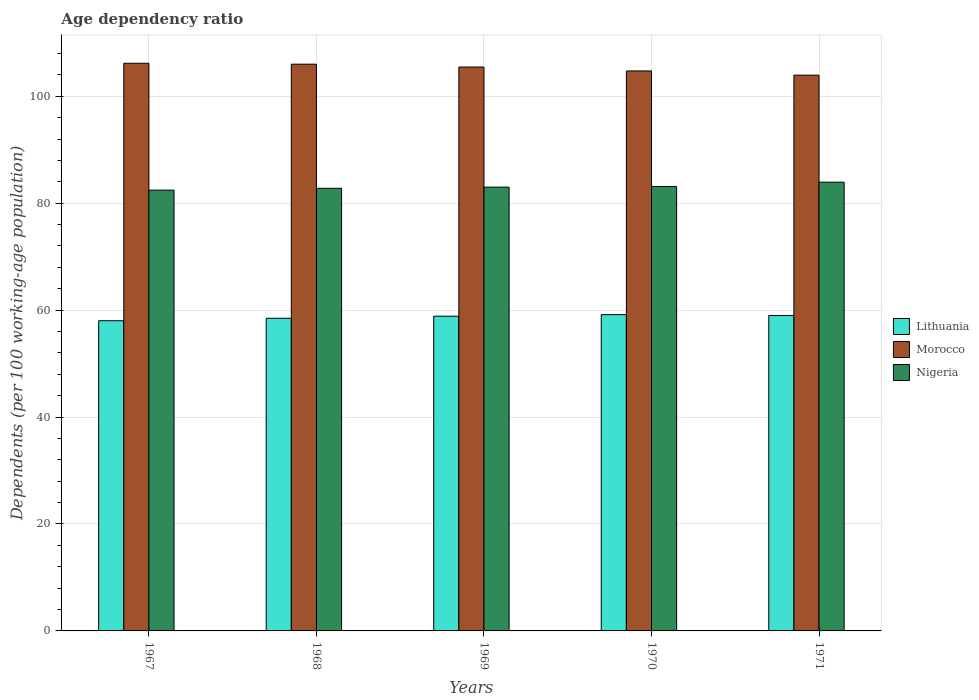How many groups of bars are there?
Offer a very short reply. 5. Are the number of bars per tick equal to the number of legend labels?
Your answer should be very brief. Yes. Are the number of bars on each tick of the X-axis equal?
Your response must be concise. Yes. How many bars are there on the 1st tick from the left?
Ensure brevity in your answer.  3. How many bars are there on the 5th tick from the right?
Offer a terse response. 3. What is the age dependency ratio in in Nigeria in 1971?
Ensure brevity in your answer.  83.94. Across all years, what is the maximum age dependency ratio in in Lithuania?
Ensure brevity in your answer.  59.16. Across all years, what is the minimum age dependency ratio in in Nigeria?
Give a very brief answer. 82.45. In which year was the age dependency ratio in in Morocco maximum?
Provide a succinct answer. 1967. In which year was the age dependency ratio in in Lithuania minimum?
Your answer should be very brief. 1967. What is the total age dependency ratio in in Morocco in the graph?
Your response must be concise. 526.37. What is the difference between the age dependency ratio in in Lithuania in 1967 and that in 1968?
Give a very brief answer. -0.46. What is the difference between the age dependency ratio in in Lithuania in 1970 and the age dependency ratio in in Morocco in 1967?
Your response must be concise. -47.02. What is the average age dependency ratio in in Morocco per year?
Ensure brevity in your answer.  105.27. In the year 1971, what is the difference between the age dependency ratio in in Morocco and age dependency ratio in in Lithuania?
Provide a short and direct response. 44.96. In how many years, is the age dependency ratio in in Lithuania greater than 96 %?
Make the answer very short. 0. What is the ratio of the age dependency ratio in in Lithuania in 1967 to that in 1968?
Your response must be concise. 0.99. Is the age dependency ratio in in Morocco in 1967 less than that in 1968?
Your answer should be compact. No. Is the difference between the age dependency ratio in in Morocco in 1968 and 1970 greater than the difference between the age dependency ratio in in Lithuania in 1968 and 1970?
Offer a very short reply. Yes. What is the difference between the highest and the second highest age dependency ratio in in Morocco?
Provide a succinct answer. 0.17. What is the difference between the highest and the lowest age dependency ratio in in Nigeria?
Make the answer very short. 1.49. In how many years, is the age dependency ratio in in Morocco greater than the average age dependency ratio in in Morocco taken over all years?
Offer a very short reply. 3. Is the sum of the age dependency ratio in in Morocco in 1967 and 1970 greater than the maximum age dependency ratio in in Lithuania across all years?
Give a very brief answer. Yes. What does the 1st bar from the left in 1968 represents?
Your answer should be compact. Lithuania. What does the 1st bar from the right in 1967 represents?
Provide a short and direct response. Nigeria. How many bars are there?
Give a very brief answer. 15. How many years are there in the graph?
Provide a short and direct response. 5. Where does the legend appear in the graph?
Offer a very short reply. Center right. How are the legend labels stacked?
Provide a short and direct response. Vertical. What is the title of the graph?
Keep it short and to the point. Age dependency ratio. Does "Tunisia" appear as one of the legend labels in the graph?
Offer a very short reply. No. What is the label or title of the X-axis?
Your answer should be very brief. Years. What is the label or title of the Y-axis?
Your answer should be very brief. Dependents (per 100 working-age population). What is the Dependents (per 100 working-age population) in Lithuania in 1967?
Your answer should be very brief. 58.02. What is the Dependents (per 100 working-age population) in Morocco in 1967?
Offer a terse response. 106.18. What is the Dependents (per 100 working-age population) in Nigeria in 1967?
Keep it short and to the point. 82.45. What is the Dependents (per 100 working-age population) in Lithuania in 1968?
Your answer should be compact. 58.48. What is the Dependents (per 100 working-age population) in Morocco in 1968?
Offer a terse response. 106.01. What is the Dependents (per 100 working-age population) in Nigeria in 1968?
Your answer should be compact. 82.8. What is the Dependents (per 100 working-age population) of Lithuania in 1969?
Provide a short and direct response. 58.87. What is the Dependents (per 100 working-age population) in Morocco in 1969?
Your answer should be compact. 105.48. What is the Dependents (per 100 working-age population) of Nigeria in 1969?
Offer a very short reply. 83.01. What is the Dependents (per 100 working-age population) in Lithuania in 1970?
Your answer should be compact. 59.16. What is the Dependents (per 100 working-age population) in Morocco in 1970?
Your response must be concise. 104.74. What is the Dependents (per 100 working-age population) of Nigeria in 1970?
Provide a short and direct response. 83.14. What is the Dependents (per 100 working-age population) of Lithuania in 1971?
Your response must be concise. 59. What is the Dependents (per 100 working-age population) in Morocco in 1971?
Keep it short and to the point. 103.96. What is the Dependents (per 100 working-age population) of Nigeria in 1971?
Make the answer very short. 83.94. Across all years, what is the maximum Dependents (per 100 working-age population) in Lithuania?
Your response must be concise. 59.16. Across all years, what is the maximum Dependents (per 100 working-age population) of Morocco?
Provide a succinct answer. 106.18. Across all years, what is the maximum Dependents (per 100 working-age population) of Nigeria?
Provide a short and direct response. 83.94. Across all years, what is the minimum Dependents (per 100 working-age population) in Lithuania?
Your answer should be compact. 58.02. Across all years, what is the minimum Dependents (per 100 working-age population) in Morocco?
Offer a very short reply. 103.96. Across all years, what is the minimum Dependents (per 100 working-age population) in Nigeria?
Give a very brief answer. 82.45. What is the total Dependents (per 100 working-age population) of Lithuania in the graph?
Your answer should be very brief. 293.53. What is the total Dependents (per 100 working-age population) of Morocco in the graph?
Your answer should be compact. 526.37. What is the total Dependents (per 100 working-age population) of Nigeria in the graph?
Provide a succinct answer. 415.33. What is the difference between the Dependents (per 100 working-age population) in Lithuania in 1967 and that in 1968?
Provide a succinct answer. -0.46. What is the difference between the Dependents (per 100 working-age population) of Morocco in 1967 and that in 1968?
Your answer should be compact. 0.17. What is the difference between the Dependents (per 100 working-age population) in Nigeria in 1967 and that in 1968?
Your response must be concise. -0.35. What is the difference between the Dependents (per 100 working-age population) in Lithuania in 1967 and that in 1969?
Make the answer very short. -0.84. What is the difference between the Dependents (per 100 working-age population) of Morocco in 1967 and that in 1969?
Your answer should be compact. 0.7. What is the difference between the Dependents (per 100 working-age population) of Nigeria in 1967 and that in 1969?
Keep it short and to the point. -0.56. What is the difference between the Dependents (per 100 working-age population) of Lithuania in 1967 and that in 1970?
Provide a succinct answer. -1.14. What is the difference between the Dependents (per 100 working-age population) of Morocco in 1967 and that in 1970?
Provide a succinct answer. 1.44. What is the difference between the Dependents (per 100 working-age population) of Nigeria in 1967 and that in 1970?
Make the answer very short. -0.69. What is the difference between the Dependents (per 100 working-age population) in Lithuania in 1967 and that in 1971?
Make the answer very short. -0.98. What is the difference between the Dependents (per 100 working-age population) in Morocco in 1967 and that in 1971?
Make the answer very short. 2.23. What is the difference between the Dependents (per 100 working-age population) in Nigeria in 1967 and that in 1971?
Keep it short and to the point. -1.49. What is the difference between the Dependents (per 100 working-age population) of Lithuania in 1968 and that in 1969?
Provide a short and direct response. -0.38. What is the difference between the Dependents (per 100 working-age population) of Morocco in 1968 and that in 1969?
Provide a succinct answer. 0.53. What is the difference between the Dependents (per 100 working-age population) of Nigeria in 1968 and that in 1969?
Keep it short and to the point. -0.22. What is the difference between the Dependents (per 100 working-age population) of Lithuania in 1968 and that in 1970?
Provide a short and direct response. -0.68. What is the difference between the Dependents (per 100 working-age population) of Morocco in 1968 and that in 1970?
Your response must be concise. 1.27. What is the difference between the Dependents (per 100 working-age population) of Nigeria in 1968 and that in 1970?
Provide a short and direct response. -0.34. What is the difference between the Dependents (per 100 working-age population) in Lithuania in 1968 and that in 1971?
Give a very brief answer. -0.51. What is the difference between the Dependents (per 100 working-age population) in Morocco in 1968 and that in 1971?
Provide a succinct answer. 2.05. What is the difference between the Dependents (per 100 working-age population) in Nigeria in 1968 and that in 1971?
Your answer should be compact. -1.14. What is the difference between the Dependents (per 100 working-age population) of Lithuania in 1969 and that in 1970?
Offer a terse response. -0.3. What is the difference between the Dependents (per 100 working-age population) in Morocco in 1969 and that in 1970?
Your response must be concise. 0.73. What is the difference between the Dependents (per 100 working-age population) in Nigeria in 1969 and that in 1970?
Keep it short and to the point. -0.12. What is the difference between the Dependents (per 100 working-age population) of Lithuania in 1969 and that in 1971?
Ensure brevity in your answer.  -0.13. What is the difference between the Dependents (per 100 working-age population) of Morocco in 1969 and that in 1971?
Your answer should be compact. 1.52. What is the difference between the Dependents (per 100 working-age population) of Nigeria in 1969 and that in 1971?
Offer a terse response. -0.93. What is the difference between the Dependents (per 100 working-age population) of Lithuania in 1970 and that in 1971?
Ensure brevity in your answer.  0.17. What is the difference between the Dependents (per 100 working-age population) in Morocco in 1970 and that in 1971?
Your response must be concise. 0.79. What is the difference between the Dependents (per 100 working-age population) in Nigeria in 1970 and that in 1971?
Offer a very short reply. -0.8. What is the difference between the Dependents (per 100 working-age population) in Lithuania in 1967 and the Dependents (per 100 working-age population) in Morocco in 1968?
Provide a short and direct response. -47.99. What is the difference between the Dependents (per 100 working-age population) of Lithuania in 1967 and the Dependents (per 100 working-age population) of Nigeria in 1968?
Give a very brief answer. -24.77. What is the difference between the Dependents (per 100 working-age population) of Morocco in 1967 and the Dependents (per 100 working-age population) of Nigeria in 1968?
Provide a succinct answer. 23.39. What is the difference between the Dependents (per 100 working-age population) of Lithuania in 1967 and the Dependents (per 100 working-age population) of Morocco in 1969?
Keep it short and to the point. -47.46. What is the difference between the Dependents (per 100 working-age population) in Lithuania in 1967 and the Dependents (per 100 working-age population) in Nigeria in 1969?
Keep it short and to the point. -24.99. What is the difference between the Dependents (per 100 working-age population) in Morocco in 1967 and the Dependents (per 100 working-age population) in Nigeria in 1969?
Offer a very short reply. 23.17. What is the difference between the Dependents (per 100 working-age population) of Lithuania in 1967 and the Dependents (per 100 working-age population) of Morocco in 1970?
Give a very brief answer. -46.72. What is the difference between the Dependents (per 100 working-age population) of Lithuania in 1967 and the Dependents (per 100 working-age population) of Nigeria in 1970?
Give a very brief answer. -25.11. What is the difference between the Dependents (per 100 working-age population) in Morocco in 1967 and the Dependents (per 100 working-age population) in Nigeria in 1970?
Keep it short and to the point. 23.05. What is the difference between the Dependents (per 100 working-age population) of Lithuania in 1967 and the Dependents (per 100 working-age population) of Morocco in 1971?
Give a very brief answer. -45.94. What is the difference between the Dependents (per 100 working-age population) of Lithuania in 1967 and the Dependents (per 100 working-age population) of Nigeria in 1971?
Ensure brevity in your answer.  -25.92. What is the difference between the Dependents (per 100 working-age population) in Morocco in 1967 and the Dependents (per 100 working-age population) in Nigeria in 1971?
Your response must be concise. 22.24. What is the difference between the Dependents (per 100 working-age population) in Lithuania in 1968 and the Dependents (per 100 working-age population) in Morocco in 1969?
Give a very brief answer. -46.99. What is the difference between the Dependents (per 100 working-age population) in Lithuania in 1968 and the Dependents (per 100 working-age population) in Nigeria in 1969?
Offer a terse response. -24.53. What is the difference between the Dependents (per 100 working-age population) of Morocco in 1968 and the Dependents (per 100 working-age population) of Nigeria in 1969?
Keep it short and to the point. 23. What is the difference between the Dependents (per 100 working-age population) of Lithuania in 1968 and the Dependents (per 100 working-age population) of Morocco in 1970?
Your answer should be very brief. -46.26. What is the difference between the Dependents (per 100 working-age population) of Lithuania in 1968 and the Dependents (per 100 working-age population) of Nigeria in 1970?
Offer a very short reply. -24.65. What is the difference between the Dependents (per 100 working-age population) of Morocco in 1968 and the Dependents (per 100 working-age population) of Nigeria in 1970?
Make the answer very short. 22.87. What is the difference between the Dependents (per 100 working-age population) in Lithuania in 1968 and the Dependents (per 100 working-age population) in Morocco in 1971?
Ensure brevity in your answer.  -45.47. What is the difference between the Dependents (per 100 working-age population) of Lithuania in 1968 and the Dependents (per 100 working-age population) of Nigeria in 1971?
Offer a terse response. -25.45. What is the difference between the Dependents (per 100 working-age population) in Morocco in 1968 and the Dependents (per 100 working-age population) in Nigeria in 1971?
Make the answer very short. 22.07. What is the difference between the Dependents (per 100 working-age population) of Lithuania in 1969 and the Dependents (per 100 working-age population) of Morocco in 1970?
Offer a terse response. -45.88. What is the difference between the Dependents (per 100 working-age population) of Lithuania in 1969 and the Dependents (per 100 working-age population) of Nigeria in 1970?
Make the answer very short. -24.27. What is the difference between the Dependents (per 100 working-age population) of Morocco in 1969 and the Dependents (per 100 working-age population) of Nigeria in 1970?
Your response must be concise. 22.34. What is the difference between the Dependents (per 100 working-age population) in Lithuania in 1969 and the Dependents (per 100 working-age population) in Morocco in 1971?
Make the answer very short. -45.09. What is the difference between the Dependents (per 100 working-age population) of Lithuania in 1969 and the Dependents (per 100 working-age population) of Nigeria in 1971?
Your answer should be compact. -25.07. What is the difference between the Dependents (per 100 working-age population) in Morocco in 1969 and the Dependents (per 100 working-age population) in Nigeria in 1971?
Provide a succinct answer. 21.54. What is the difference between the Dependents (per 100 working-age population) in Lithuania in 1970 and the Dependents (per 100 working-age population) in Morocco in 1971?
Make the answer very short. -44.79. What is the difference between the Dependents (per 100 working-age population) in Lithuania in 1970 and the Dependents (per 100 working-age population) in Nigeria in 1971?
Ensure brevity in your answer.  -24.77. What is the difference between the Dependents (per 100 working-age population) of Morocco in 1970 and the Dependents (per 100 working-age population) of Nigeria in 1971?
Give a very brief answer. 20.81. What is the average Dependents (per 100 working-age population) of Lithuania per year?
Provide a short and direct response. 58.71. What is the average Dependents (per 100 working-age population) in Morocco per year?
Give a very brief answer. 105.27. What is the average Dependents (per 100 working-age population) in Nigeria per year?
Offer a terse response. 83.07. In the year 1967, what is the difference between the Dependents (per 100 working-age population) of Lithuania and Dependents (per 100 working-age population) of Morocco?
Offer a very short reply. -48.16. In the year 1967, what is the difference between the Dependents (per 100 working-age population) in Lithuania and Dependents (per 100 working-age population) in Nigeria?
Offer a terse response. -24.43. In the year 1967, what is the difference between the Dependents (per 100 working-age population) of Morocco and Dependents (per 100 working-age population) of Nigeria?
Provide a succinct answer. 23.73. In the year 1968, what is the difference between the Dependents (per 100 working-age population) in Lithuania and Dependents (per 100 working-age population) in Morocco?
Offer a terse response. -47.52. In the year 1968, what is the difference between the Dependents (per 100 working-age population) in Lithuania and Dependents (per 100 working-age population) in Nigeria?
Your response must be concise. -24.31. In the year 1968, what is the difference between the Dependents (per 100 working-age population) in Morocco and Dependents (per 100 working-age population) in Nigeria?
Provide a succinct answer. 23.21. In the year 1969, what is the difference between the Dependents (per 100 working-age population) in Lithuania and Dependents (per 100 working-age population) in Morocco?
Offer a terse response. -46.61. In the year 1969, what is the difference between the Dependents (per 100 working-age population) of Lithuania and Dependents (per 100 working-age population) of Nigeria?
Ensure brevity in your answer.  -24.15. In the year 1969, what is the difference between the Dependents (per 100 working-age population) in Morocco and Dependents (per 100 working-age population) in Nigeria?
Ensure brevity in your answer.  22.47. In the year 1970, what is the difference between the Dependents (per 100 working-age population) in Lithuania and Dependents (per 100 working-age population) in Morocco?
Offer a very short reply. -45.58. In the year 1970, what is the difference between the Dependents (per 100 working-age population) in Lithuania and Dependents (per 100 working-age population) in Nigeria?
Make the answer very short. -23.97. In the year 1970, what is the difference between the Dependents (per 100 working-age population) of Morocco and Dependents (per 100 working-age population) of Nigeria?
Your answer should be compact. 21.61. In the year 1971, what is the difference between the Dependents (per 100 working-age population) of Lithuania and Dependents (per 100 working-age population) of Morocco?
Offer a terse response. -44.96. In the year 1971, what is the difference between the Dependents (per 100 working-age population) of Lithuania and Dependents (per 100 working-age population) of Nigeria?
Make the answer very short. -24.94. In the year 1971, what is the difference between the Dependents (per 100 working-age population) in Morocco and Dependents (per 100 working-age population) in Nigeria?
Provide a short and direct response. 20.02. What is the ratio of the Dependents (per 100 working-age population) in Nigeria in 1967 to that in 1968?
Your answer should be compact. 1. What is the ratio of the Dependents (per 100 working-age population) of Lithuania in 1967 to that in 1969?
Your answer should be compact. 0.99. What is the ratio of the Dependents (per 100 working-age population) of Morocco in 1967 to that in 1969?
Provide a succinct answer. 1.01. What is the ratio of the Dependents (per 100 working-age population) in Lithuania in 1967 to that in 1970?
Give a very brief answer. 0.98. What is the ratio of the Dependents (per 100 working-age population) of Morocco in 1967 to that in 1970?
Ensure brevity in your answer.  1.01. What is the ratio of the Dependents (per 100 working-age population) in Nigeria in 1967 to that in 1970?
Give a very brief answer. 0.99. What is the ratio of the Dependents (per 100 working-age population) of Lithuania in 1967 to that in 1971?
Your answer should be very brief. 0.98. What is the ratio of the Dependents (per 100 working-age population) in Morocco in 1967 to that in 1971?
Ensure brevity in your answer.  1.02. What is the ratio of the Dependents (per 100 working-age population) in Nigeria in 1967 to that in 1971?
Provide a short and direct response. 0.98. What is the ratio of the Dependents (per 100 working-age population) in Lithuania in 1968 to that in 1969?
Your answer should be compact. 0.99. What is the ratio of the Dependents (per 100 working-age population) in Nigeria in 1968 to that in 1969?
Your answer should be compact. 1. What is the ratio of the Dependents (per 100 working-age population) of Lithuania in 1968 to that in 1970?
Ensure brevity in your answer.  0.99. What is the ratio of the Dependents (per 100 working-age population) in Morocco in 1968 to that in 1970?
Provide a succinct answer. 1.01. What is the ratio of the Dependents (per 100 working-age population) of Nigeria in 1968 to that in 1970?
Your answer should be very brief. 1. What is the ratio of the Dependents (per 100 working-age population) in Morocco in 1968 to that in 1971?
Your answer should be compact. 1.02. What is the ratio of the Dependents (per 100 working-age population) of Nigeria in 1968 to that in 1971?
Make the answer very short. 0.99. What is the ratio of the Dependents (per 100 working-age population) in Lithuania in 1969 to that in 1970?
Your answer should be compact. 0.99. What is the ratio of the Dependents (per 100 working-age population) of Nigeria in 1969 to that in 1970?
Your response must be concise. 1. What is the ratio of the Dependents (per 100 working-age population) of Lithuania in 1969 to that in 1971?
Make the answer very short. 1. What is the ratio of the Dependents (per 100 working-age population) of Morocco in 1969 to that in 1971?
Give a very brief answer. 1.01. What is the ratio of the Dependents (per 100 working-age population) in Lithuania in 1970 to that in 1971?
Make the answer very short. 1. What is the ratio of the Dependents (per 100 working-age population) in Morocco in 1970 to that in 1971?
Give a very brief answer. 1.01. What is the difference between the highest and the second highest Dependents (per 100 working-age population) in Lithuania?
Ensure brevity in your answer.  0.17. What is the difference between the highest and the second highest Dependents (per 100 working-age population) in Morocco?
Ensure brevity in your answer.  0.17. What is the difference between the highest and the second highest Dependents (per 100 working-age population) of Nigeria?
Make the answer very short. 0.8. What is the difference between the highest and the lowest Dependents (per 100 working-age population) of Lithuania?
Offer a very short reply. 1.14. What is the difference between the highest and the lowest Dependents (per 100 working-age population) in Morocco?
Provide a short and direct response. 2.23. What is the difference between the highest and the lowest Dependents (per 100 working-age population) in Nigeria?
Ensure brevity in your answer.  1.49. 